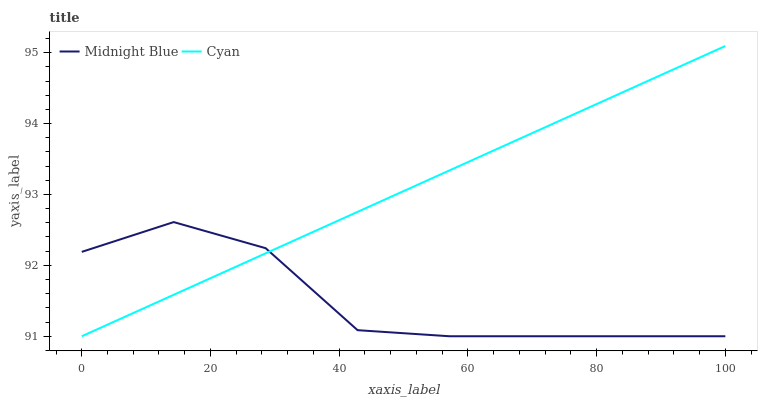Does Midnight Blue have the minimum area under the curve?
Answer yes or no. Yes. Does Cyan have the maximum area under the curve?
Answer yes or no. Yes. Does Midnight Blue have the maximum area under the curve?
Answer yes or no. No. Is Cyan the smoothest?
Answer yes or no. Yes. Is Midnight Blue the roughest?
Answer yes or no. Yes. Is Midnight Blue the smoothest?
Answer yes or no. No. Does Midnight Blue have the highest value?
Answer yes or no. No. 